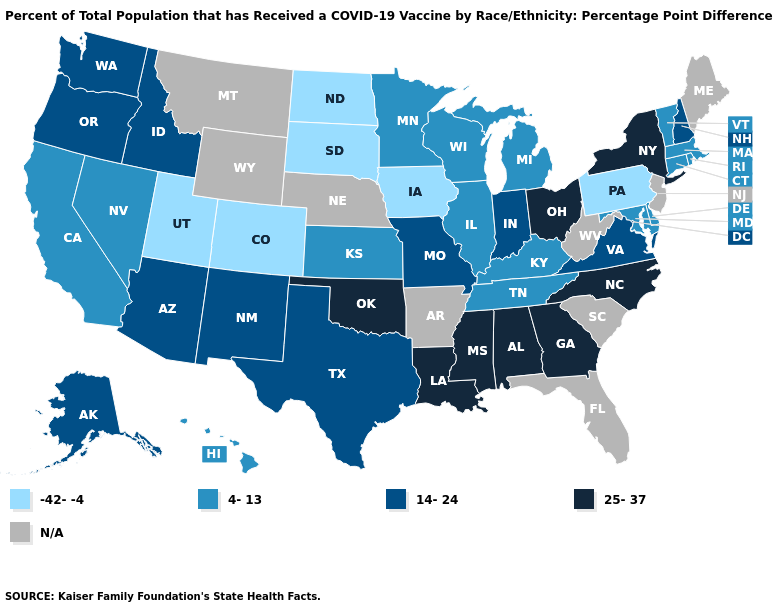What is the value of Nebraska?
Be succinct. N/A. Does the map have missing data?
Answer briefly. Yes. What is the lowest value in the West?
Be succinct. -42--4. What is the value of Virginia?
Short answer required. 14-24. What is the value of Montana?
Write a very short answer. N/A. What is the lowest value in the USA?
Quick response, please. -42--4. What is the lowest value in the West?
Short answer required. -42--4. What is the value of Iowa?
Write a very short answer. -42--4. Which states have the lowest value in the South?
Quick response, please. Delaware, Kentucky, Maryland, Tennessee. What is the value of Kentucky?
Give a very brief answer. 4-13. Which states hav the highest value in the MidWest?
Keep it brief. Ohio. 